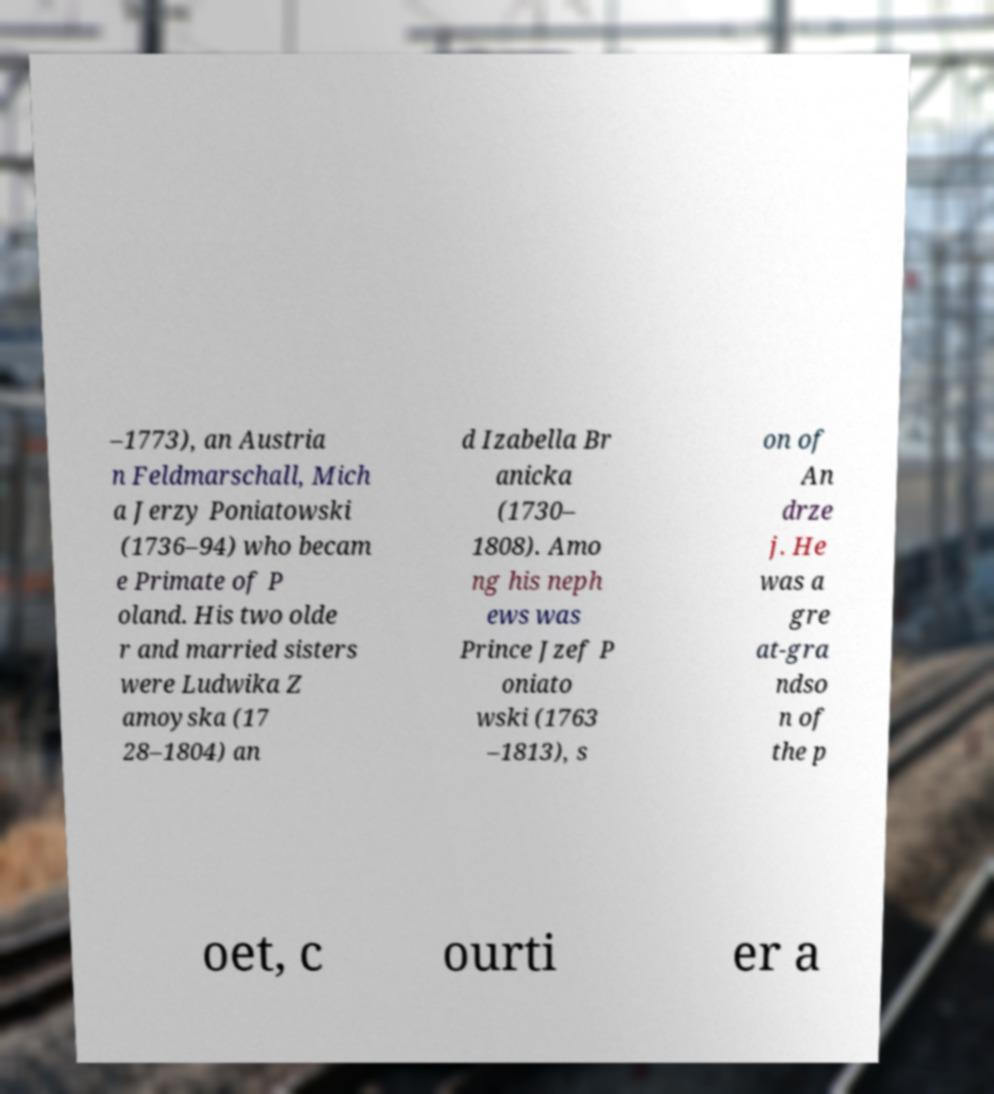I need the written content from this picture converted into text. Can you do that? –1773), an Austria n Feldmarschall, Mich a Jerzy Poniatowski (1736–94) who becam e Primate of P oland. His two olde r and married sisters were Ludwika Z amoyska (17 28–1804) an d Izabella Br anicka (1730– 1808). Amo ng his neph ews was Prince Jzef P oniato wski (1763 –1813), s on of An drze j. He was a gre at-gra ndso n of the p oet, c ourti er a 